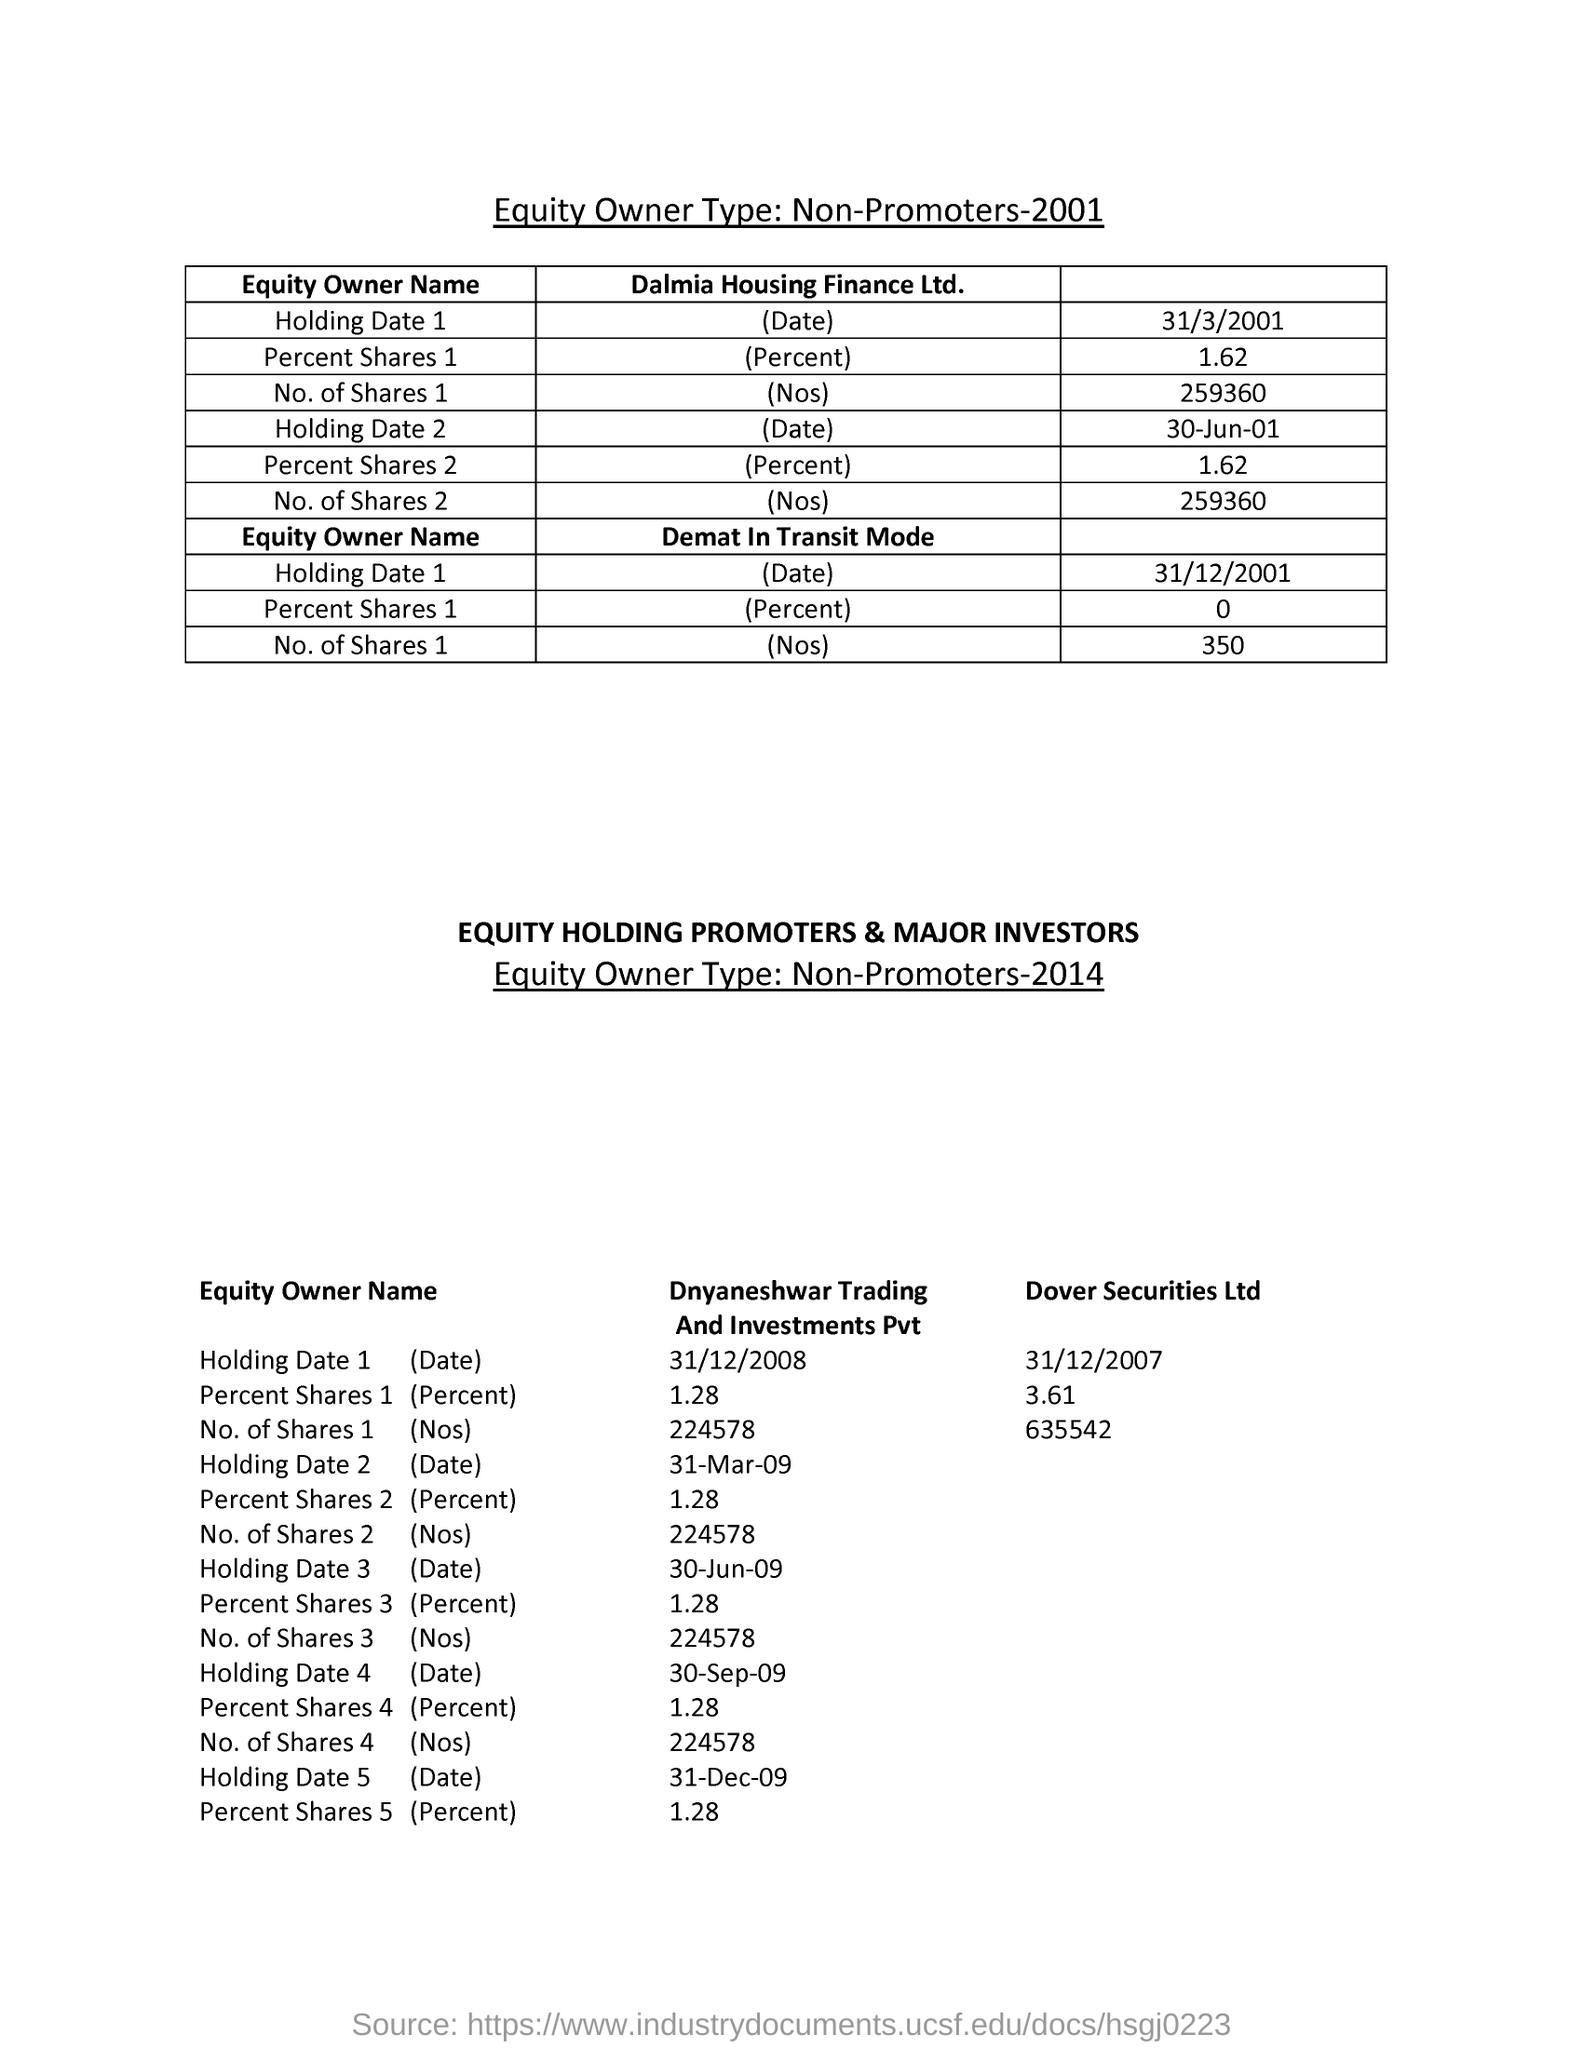How much is the Percent Shares 1 for Dalmia Housing Finance Ltd. ?
Give a very brief answer. 1.62. What is the Holding Date 1 of Dalmia Housing Finance Ltd. ?
Ensure brevity in your answer.  31/3/2001. What is the No. of Shares 1 for Dalmia Housing Finance Ltd. ?
Ensure brevity in your answer.  259360. What is the Holding Date 1 for Dover Securities Ltd?
Your answer should be very brief. 31/12/2007. What is the No. of Shares 1 for Dover Securities Ltd?
Provide a succinct answer. 635542. How much is the Percent Shares 2 for Dnyaneshwar Trading And Investments  Pvt?
Keep it short and to the point. 1.28. 